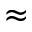Convert formula to latex. <formula><loc_0><loc_0><loc_500><loc_500>\approx</formula> 